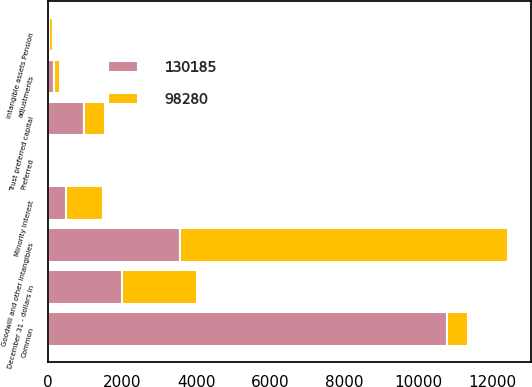Convert chart to OTSL. <chart><loc_0><loc_0><loc_500><loc_500><stacked_bar_chart><ecel><fcel>December 31 - dollars in<fcel>Common<fcel>Preferred<fcel>Trust preferred capital<fcel>Minority interest<fcel>Goodwill and other intangibles<fcel>intangible assets Pension<fcel>adjustments<nl><fcel>98280<fcel>2007<fcel>572<fcel>7<fcel>572<fcel>985<fcel>8853<fcel>119<fcel>177<nl><fcel>130185<fcel>2006<fcel>10781<fcel>7<fcel>965<fcel>494<fcel>3566<fcel>26<fcel>148<nl></chart> 